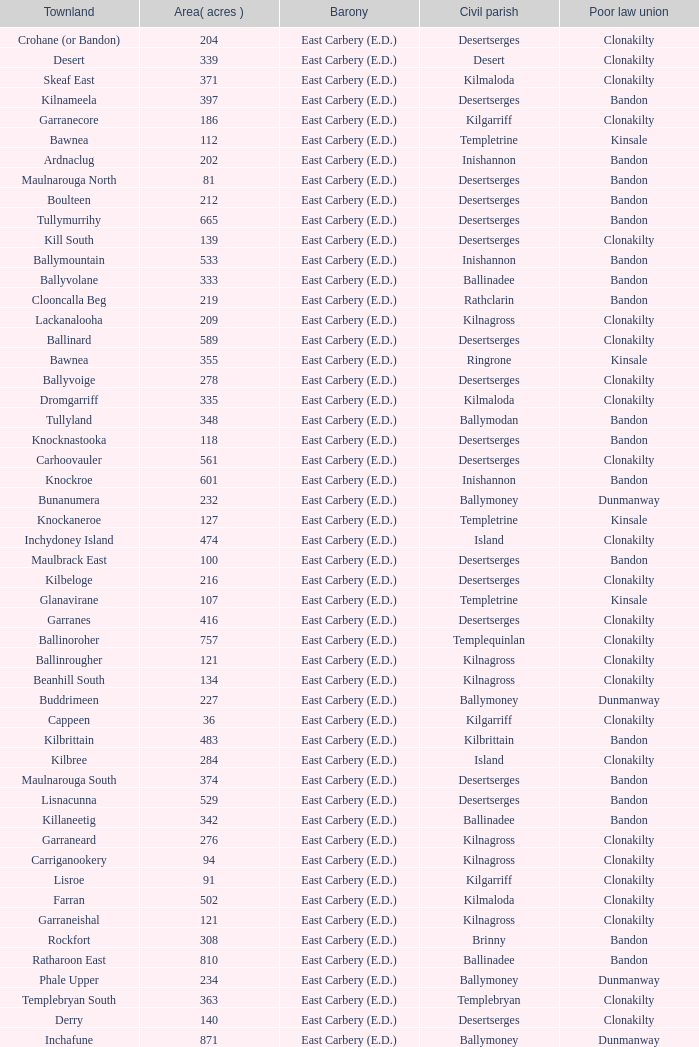What is the poor law union of the Kilmaloda townland? Clonakilty. Give me the full table as a dictionary. {'header': ['Townland', 'Area( acres )', 'Barony', 'Civil parish', 'Poor law union'], 'rows': [['Crohane (or Bandon)', '204', 'East Carbery (E.D.)', 'Desertserges', 'Clonakilty'], ['Desert', '339', 'East Carbery (E.D.)', 'Desert', 'Clonakilty'], ['Skeaf East', '371', 'East Carbery (E.D.)', 'Kilmaloda', 'Clonakilty'], ['Kilnameela', '397', 'East Carbery (E.D.)', 'Desertserges', 'Bandon'], ['Garranecore', '186', 'East Carbery (E.D.)', 'Kilgarriff', 'Clonakilty'], ['Bawnea', '112', 'East Carbery (E.D.)', 'Templetrine', 'Kinsale'], ['Ardnaclug', '202', 'East Carbery (E.D.)', 'Inishannon', 'Bandon'], ['Maulnarouga North', '81', 'East Carbery (E.D.)', 'Desertserges', 'Bandon'], ['Boulteen', '212', 'East Carbery (E.D.)', 'Desertserges', 'Bandon'], ['Tullymurrihy', '665', 'East Carbery (E.D.)', 'Desertserges', 'Bandon'], ['Kill South', '139', 'East Carbery (E.D.)', 'Desertserges', 'Clonakilty'], ['Ballymountain', '533', 'East Carbery (E.D.)', 'Inishannon', 'Bandon'], ['Ballyvolane', '333', 'East Carbery (E.D.)', 'Ballinadee', 'Bandon'], ['Clooncalla Beg', '219', 'East Carbery (E.D.)', 'Rathclarin', 'Bandon'], ['Lackanalooha', '209', 'East Carbery (E.D.)', 'Kilnagross', 'Clonakilty'], ['Ballinard', '589', 'East Carbery (E.D.)', 'Desertserges', 'Clonakilty'], ['Bawnea', '355', 'East Carbery (E.D.)', 'Ringrone', 'Kinsale'], ['Ballyvoige', '278', 'East Carbery (E.D.)', 'Desertserges', 'Clonakilty'], ['Dromgarriff', '335', 'East Carbery (E.D.)', 'Kilmaloda', 'Clonakilty'], ['Tullyland', '348', 'East Carbery (E.D.)', 'Ballymodan', 'Bandon'], ['Knocknastooka', '118', 'East Carbery (E.D.)', 'Desertserges', 'Bandon'], ['Carhoovauler', '561', 'East Carbery (E.D.)', 'Desertserges', 'Clonakilty'], ['Knockroe', '601', 'East Carbery (E.D.)', 'Inishannon', 'Bandon'], ['Bunanumera', '232', 'East Carbery (E.D.)', 'Ballymoney', 'Dunmanway'], ['Knockaneroe', '127', 'East Carbery (E.D.)', 'Templetrine', 'Kinsale'], ['Inchydoney Island', '474', 'East Carbery (E.D.)', 'Island', 'Clonakilty'], ['Maulbrack East', '100', 'East Carbery (E.D.)', 'Desertserges', 'Bandon'], ['Kilbeloge', '216', 'East Carbery (E.D.)', 'Desertserges', 'Clonakilty'], ['Glanavirane', '107', 'East Carbery (E.D.)', 'Templetrine', 'Kinsale'], ['Garranes', '416', 'East Carbery (E.D.)', 'Desertserges', 'Clonakilty'], ['Ballinoroher', '757', 'East Carbery (E.D.)', 'Templequinlan', 'Clonakilty'], ['Ballinrougher', '121', 'East Carbery (E.D.)', 'Kilnagross', 'Clonakilty'], ['Beanhill South', '134', 'East Carbery (E.D.)', 'Kilnagross', 'Clonakilty'], ['Buddrimeen', '227', 'East Carbery (E.D.)', 'Ballymoney', 'Dunmanway'], ['Cappeen', '36', 'East Carbery (E.D.)', 'Kilgarriff', 'Clonakilty'], ['Kilbrittain', '483', 'East Carbery (E.D.)', 'Kilbrittain', 'Bandon'], ['Kilbree', '284', 'East Carbery (E.D.)', 'Island', 'Clonakilty'], ['Maulnarouga South', '374', 'East Carbery (E.D.)', 'Desertserges', 'Bandon'], ['Lisnacunna', '529', 'East Carbery (E.D.)', 'Desertserges', 'Bandon'], ['Killaneetig', '342', 'East Carbery (E.D.)', 'Ballinadee', 'Bandon'], ['Garraneard', '276', 'East Carbery (E.D.)', 'Kilnagross', 'Clonakilty'], ['Carriganookery', '94', 'East Carbery (E.D.)', 'Kilnagross', 'Clonakilty'], ['Lisroe', '91', 'East Carbery (E.D.)', 'Kilgarriff', 'Clonakilty'], ['Farran', '502', 'East Carbery (E.D.)', 'Kilmaloda', 'Clonakilty'], ['Garraneishal', '121', 'East Carbery (E.D.)', 'Kilnagross', 'Clonakilty'], ['Rockfort', '308', 'East Carbery (E.D.)', 'Brinny', 'Bandon'], ['Ratharoon East', '810', 'East Carbery (E.D.)', 'Ballinadee', 'Bandon'], ['Phale Upper', '234', 'East Carbery (E.D.)', 'Ballymoney', 'Dunmanway'], ['Templebryan South', '363', 'East Carbery (E.D.)', 'Templebryan', 'Clonakilty'], ['Derry', '140', 'East Carbery (E.D.)', 'Desertserges', 'Clonakilty'], ['Inchafune', '871', 'East Carbery (E.D.)', 'Ballymoney', 'Dunmanway'], ['Moanarone', '235', 'East Carbery (E.D.)', 'Ballymodan', 'Bandon'], ['Knockmacool', '241', 'East Carbery (E.D.)', 'Desertserges', 'Bandon'], ['Shanaway East', '386', 'East Carbery (E.D.)', 'Ballymoney', 'Dunmanway'], ['Youghals', '109', 'East Carbery (E.D.)', 'Island', 'Clonakilty'], ['Farranagow', '99', 'East Carbery (E.D.)', 'Inishannon', 'Bandon'], ['Kilgobbin', '1263', 'East Carbery (E.D.)', 'Ballinadee', 'Bandon'], ['Ballymacowen', '522', 'East Carbery (E.D.)', 'Kilnagross', 'Clonakilty'], ['Kilshinahan', '528', 'East Carbery (E.D.)', 'Kilbrittain', 'Bandon'], ['Cloghmacsimon', '258', 'East Carbery (E.D.)', 'Ballymodan', 'Bandon'], ['Shanaway West', '266', 'East Carbery (E.D.)', 'Ballymoney', 'Dunmanway'], ['Lisheen', '44', 'East Carbery (E.D.)', 'Templetrine', 'Kinsale'], ['Garraneanasig', '270', 'East Carbery (E.D.)', 'Ringrone', 'Kinsale'], ['Crohane West', '69', 'East Carbery (E.D.)', 'Desertserges', 'Clonakilty'], ['Knockanreagh', '139', 'East Carbery (E.D.)', 'Ballymodan', 'Bandon'], ['Castlederry', '148', 'East Carbery (E.D.)', 'Desertserges', 'Clonakilty'], ['Maulbrack West', '242', 'East Carbery (E.D.)', 'Desertserges', 'Bandon'], ['Reenroe', '123', 'East Carbery (E.D.)', 'Kilgarriff', 'Clonakilty'], ['Ballybeg', '261', 'East Carbery (E.D.)', 'Kilbrittain', 'Bandon'], ['Derrigra', '177', 'East Carbery (E.D.)', 'Ballymoney', 'Dunmanway'], ['Beanhill North', '108', 'East Carbery (E.D.)', 'Kilnagross', 'Clonakilty'], ['Ballinvronig', '319', 'East Carbery (E.D.)', 'Templetrine', 'Kinsale'], ['Knockeenbwee Upper', '229', 'East Carbery (E.D.)', 'Dromdaleague', 'Skibbereen'], ['Clogagh North', '173', 'East Carbery (E.D.)', 'Kilmaloda', 'Clonakilty'], ['Crohane East', '108', 'East Carbery (E.D.)', 'Desertserges', 'Clonakilty'], ['Ballylangley', '288', 'East Carbery (E.D.)', 'Ballymodan', 'Bandon'], ['Knockacullen', '381', 'East Carbery (E.D.)', 'Desertserges', 'Clonakilty'], ['Clashafree', '477', 'East Carbery (E.D.)', 'Ballymodan', 'Bandon'], ['Scartagh', '186', 'East Carbery (E.D.)', 'Kilgarriff', 'Clonakilty'], ['Tawnies Upper', '321', 'East Carbery (E.D.)', 'Kilgarriff', 'Clonakilty'], ['Templebryan North', '436', 'East Carbery (E.D.)', 'Templebryan', 'Clonakilty'], ['Miles', '268', 'East Carbery (E.D.)', 'Kilgarriff', 'Clonakilty'], ['Knocknagappul', '507', 'East Carbery (E.D.)', 'Ballinadee', 'Bandon'], ['Knocks', '540', 'East Carbery (E.D.)', 'Desertserges', 'Clonakilty'], ['Maulrour', '340', 'East Carbery (E.D.)', 'Kilmaloda', 'Clonakilty'], ['Garranefeen', '478', 'East Carbery (E.D.)', 'Rathclarin', 'Bandon'], ['Dromgarriff West', '138', 'East Carbery (E.D.)', 'Kilnagross', 'Clonakilty'], ['Kilmacsimon', '219', 'East Carbery (E.D.)', 'Ballinadee', 'Bandon'], ['Tawnies Lower', '238', 'East Carbery (E.D.)', 'Kilgarriff', 'Clonakilty'], ['Lisheenaleen', '267', 'East Carbery (E.D.)', 'Rathclarin', 'Bandon'], ['Baltinakin', '333', 'East Carbery (E.D.)', 'Kilbrittain', 'Bandon'], ['Curraghcrowly West', '242', 'East Carbery (E.D.)', 'Ballymoney', 'Dunmanway'], ['Ahalisky', '886', 'East Carbery (E.D.)', 'Kilmaloda', 'Clonakilty'], ['Cloncouse', '241', 'East Carbery (E.D.)', 'Ballinadee', 'Bandon'], ['Dromgarriff East', '385', 'East Carbery (E.D.)', 'Kilnagross', 'Clonakilty'], ['Tullig', '135', 'East Carbery (E.D.)', 'Kilmaloda', 'Clonakilty'], ['Maulnageragh', '135', 'East Carbery (E.D.)', 'Kilnagross', 'Clonakilty'], ['Garranereagh', '398', 'East Carbery (E.D.)', 'Ringrone', 'Kinsale'], ['Clonbouig', '219', 'East Carbery (E.D.)', 'Ringrone', 'Kinsale'], ['Dromkeen', '673', 'East Carbery (E.D.)', 'Inishannon', 'Bandon'], ['Carrigcannon', '59', 'East Carbery (E.D.)', 'Ballymodan', 'Bandon'], ['Knocknacurra', '422', 'East Carbery (E.D.)', 'Ballinadee', 'Bandon'], ['Hacketstown', '182', 'East Carbery (E.D.)', 'Templetrine', 'Kinsale'], ['Lisbehegh', '255', 'East Carbery (E.D.)', 'Desertserges', 'Clonakilty'], ['Fourcuil', '125', 'East Carbery (E.D.)', 'Kilgarriff', 'Clonakilty'], ['Ardkitt West', '407', 'East Carbery (E.D.)', 'Desertserges', 'Bandon'], ['Carrig', '410', 'East Carbery (E.D.)', 'Kilmaloda', 'Clonakilty'], ['Crohane (or Bandon)', '250', 'East Carbery (E.D.)', 'Kilnagross', 'Clonakilty'], ['Killeen', '309', 'East Carbery (E.D.)', 'Desertserges', 'Clonakilty'], ['Knocknanuss', '394', 'East Carbery (E.D.)', 'Desertserges', 'Clonakilty'], ['Carrig', '165', 'East Carbery (E.D.)', 'Templequinlan', 'Clonakilty'], ['Garranbeg', '170', 'East Carbery (E.D.)', 'Ballymodan', 'Bandon'], ['Glanavirane', '91', 'East Carbery (E.D.)', 'Ringrone', 'Kinsale'], ['Knockeencon', '108', 'East Carbery (E.D.)', 'Tullagh', 'Skibbereen'], ['Clonbouig', '209', 'East Carbery (E.D.)', 'Templetrine', 'Kinsale'], ['Aghyohil Beg', '94', 'East Carbery (E.D.)', 'Desertserges', 'Bandon'], ['Breaghna', '333', 'East Carbery (E.D.)', 'Desertserges', 'Bandon'], ['Ballydownis West', '60', 'East Carbery (E.D.)', 'Templetrine', 'Kinsale'], ['Curraghcrowly East', '327', 'East Carbery (E.D.)', 'Ballymoney', 'Dunmanway'], ['Killanamaul', '220', 'East Carbery (E.D.)', 'Kilbrittain', 'Bandon'], ['Corravreeda East', '258', 'East Carbery (E.D.)', 'Ballymodan', 'Bandon'], ['Fourcuil', '244', 'East Carbery (E.D.)', 'Templebryan', 'Clonakilty'], ['Ballydownis', '73', 'East Carbery (E.D.)', 'Ringrone', 'Kinsale'], ['Cloonderreen', '291', 'East Carbery (E.D.)', 'Rathclarin', 'Bandon'], ['Kilrush', '189', 'East Carbery (E.D.)', 'Desertserges', 'Bandon'], ['Cripplehill', '125', 'East Carbery (E.D.)', 'Ballymodan', 'Bandon'], ['Skeaf West', '477', 'East Carbery (E.D.)', 'Kilmaloda', 'Clonakilty'], ['Ballynacarriga', '124', 'East Carbery (E.D.)', 'Ballymoney', 'Dunmanway'], ['Derrigra West', '320', 'East Carbery (E.D.)', 'Ballymoney', 'Dunmanway'], ['Knockskagh', '489', 'East Carbery (E.D.)', 'Kilgarriff', 'Clonakilty'], ['Steilaneigh', '42', 'East Carbery (E.D.)', 'Templetrine', 'Kinsale'], ['Farrannasheshery', '304', 'East Carbery (E.D.)', 'Desertserges', 'Bandon'], ['Ballynascubbig', '272', 'East Carbery (E.D.)', 'Templetrine', 'Kinsale'], ['Rochestown', '104', 'East Carbery (E.D.)', 'Templetrine', 'Kinsale'], ['Shanaway Middle', '296', 'East Carbery (E.D.)', 'Ballymoney', 'Dunmanway'], ['Currarane', '100', 'East Carbery (E.D.)', 'Templetrine', 'Kinsale'], ['Derrymeeleen', '441', 'East Carbery (E.D.)', 'Desertserges', 'Clonakilty'], ['Knockbrown', '510', 'East Carbery (E.D.)', 'Kilmaloda', 'Bandon'], ['Clogagh South', '282', 'East Carbery (E.D.)', 'Kilmaloda', 'Clonakilty'], ['Knockbrown', '312', 'East Carbery (E.D.)', 'Kilbrittain', 'Bandon'], ['Kilvinane', '199', 'East Carbery (E.D.)', 'Ballymoney', 'Dunmanway'], ['Maulskinlahane', '245', 'East Carbery (E.D.)', 'Kilbrittain', 'Bandon'], ['Glanavaud', '98', 'East Carbery (E.D.)', 'Ringrone', 'Kinsale'], ['Barleyfield', '795', 'East Carbery (E.D.)', 'Rathclarin', 'Bandon'], ['Ardea', '295', 'East Carbery (E.D.)', 'Ballymoney', 'Dunmanway'], ['Drombofinny', '86', 'East Carbery (E.D.)', 'Desertserges', 'Bandon'], ['Glanduff', '464', 'East Carbery (E.D.)', 'Rathclarin', 'Bandon'], ['Clooncalla More', '543', 'East Carbery (E.D.)', 'Rathclarin', 'Bandon'], ['Skevanish', '359', 'East Carbery (E.D.)', 'Inishannon', 'Bandon'], ['Rockhouse', '82', 'East Carbery (E.D.)', 'Ballinadee', 'Bandon'], ['Farrannagark', '290', 'East Carbery (E.D.)', 'Rathclarin', 'Bandon'], ['Burren', '639', 'East Carbery (E.D.)', 'Rathclarin', 'Bandon'], ['Grillagh', '136', 'East Carbery (E.D.)', 'Kilnagross', 'Clonakilty'], ['Curranure', '362', 'East Carbery (E.D.)', 'Inishannon', 'Bandon'], ['Kilvurra', '356', 'East Carbery (E.D.)', 'Ballymoney', 'Dunmanway'], ['Edencurra', '516', 'East Carbery (E.D.)', 'Ballymoney', 'Dunmanway'], ['Shanakill', '197', 'East Carbery (E.D.)', 'Rathclarin', 'Bandon'], ['Ardkitt East', '283', 'East Carbery (E.D.)', 'Desertserges', 'Bandon'], ['Carrigcannon', '122', 'East Carbery (E.D.)', 'Ringrone', 'Kinsale'], ['Crohane', '91', 'East Carbery (E.D.)', 'Kilnagross', 'Clonakilty'], ['Kilmaloda', '634', 'East Carbery (E.D.)', 'Kilmaloda', 'Clonakilty'], ['Carrigeen', '210', 'East Carbery (E.D.)', 'Ballymoney', 'Dunmanway'], ['Currane', '156', 'East Carbery (E.D.)', 'Desertserges', 'Clonakilty'], ['Corravreeda West', '169', 'East Carbery (E.D.)', 'Ballymodan', 'Bandon'], ['Reengarrigeen', '560', 'East Carbery (E.D.)', 'Kilmaloda', 'Clonakilty'], ['Knoppoge', '567', 'East Carbery (E.D.)', 'Kilbrittain', 'Bandon'], ['Kilcaskan', '221', 'East Carbery (E.D.)', 'Ballymoney', 'Dunmanway'], ['Skeaf', '452', 'East Carbery (E.D.)', 'Kilmaloda', 'Clonakilty'], ['Carhoogarriff', '281', 'East Carbery (E.D.)', 'Kilnagross', 'Clonakilty'], ['Coolmain', '450', 'East Carbery (E.D.)', 'Ringrone', 'Kinsale'], ['Killeens', '132', 'East Carbery (E.D.)', 'Templetrine', 'Kinsale'], ['Lissaphooca', '513', 'East Carbery (E.D.)', 'Ballymodan', 'Bandon'], ['Phale Lower', '287', 'East Carbery (E.D.)', 'Ballymoney', 'Dunmanway'], ['Garranecore', '144', 'East Carbery (E.D.)', 'Templebryan', 'Clonakilty'], ['Bally More', '418', 'East Carbery (E.D.)', 'Kilbrittain', 'Bandon'], ['Kill North', '136', 'East Carbery (E.D.)', 'Desertserges', 'Clonakilty'], ['Knockeenbwee Lower', '213', 'East Carbery (E.D.)', 'Dromdaleague', 'Skibbereen'], ['Garranure', '436', 'East Carbery (E.D.)', 'Ballymoney', 'Dunmanway'], ['Carrigroe', '276', 'East Carbery (E.D.)', 'Desertserges', 'Bandon'], ['Ratharoon West', '383', 'East Carbery (E.D.)', 'Ballinadee', 'Bandon'], ['Clogheenavodig', '70', 'East Carbery (E.D.)', 'Ballymodan', 'Bandon'], ['Ardacrow', '519', 'East Carbery (E.D.)', 'Rathclarin', 'Bandon'], ['Currabeg', '173', 'East Carbery (E.D.)', 'Ballymoney', 'Dunmanway'], ['Rathdrought', '1242', 'East Carbery (E.D.)', 'Ballinadee', 'Bandon'], ['Cloghane', '488', 'East Carbery (E.D.)', 'Ballinadee', 'Bandon'], ['Monteen', '589', 'East Carbery (E.D.)', 'Kilmaloda', 'Clonakilty'], ['Cashelisky', '368', 'East Carbery (E.D.)', 'Island', 'Clonakilty'], ['Aghyohil More', '178', 'East Carbery (E.D.)', 'Desertserges', 'Bandon'], ['Clashreagh', '132', 'East Carbery (E.D.)', 'Templetrine', 'Kinsale'], ['Cloheen', '360', 'East Carbery (E.D.)', 'Kilgarriff', 'Clonakilty'], ['Kildarra', '463', 'East Carbery (E.D.)', 'Ballinadee', 'Bandon'], ['Kilgarriff', '835', 'East Carbery (E.D.)', 'Kilgarriff', 'Clonakilty'], ['Tullyland', '506', 'East Carbery (E.D.)', 'Ballinadee', 'Bandon'], ['Lackenagobidane', '48', 'East Carbery (E.D.)', 'Island', 'Clonakilty'], ['Maulnaskehy', '14', 'East Carbery (E.D.)', 'Kilgarriff', 'Clonakilty'], ['Grillagh', '316', 'East Carbery (E.D.)', 'Ballymoney', 'Dunmanway'], ['Ballycatteen', '338', 'East Carbery (E.D.)', 'Rathclarin', 'Bandon'], ['Ballydownis East', '42', 'East Carbery (E.D.)', 'Templetrine', 'Kinsale'], ['Killavarrig', '708', 'East Carbery (E.D.)', 'Timoleague', 'Clonakilty'], ['Garranelahan', '126', 'East Carbery (E.D.)', 'Desertserges', 'Bandon'], ['Curraghgrane More', '110', 'East Carbery (E.D.)', 'Desert', 'Clonakilty'], ['Currarane', '271', 'East Carbery (E.D.)', 'Ringrone', 'Kinsale'], ['Burrane', '410', 'East Carbery (E.D.)', 'Kilmaloda', 'Clonakilty'], ['Lisselane', '429', 'East Carbery (E.D.)', 'Kilnagross', 'Clonakilty'], ['Knockaneady', '393', 'East Carbery (E.D.)', 'Ballymoney', 'Dunmanway'], ['Kilmoylerane North', '306', 'East Carbery (E.D.)', 'Desertserges', 'Clonakilty'], ['Cripplehill', '93', 'East Carbery (E.D.)', 'Kilbrittain', 'Bandon'], ['Madame', '273', 'East Carbery (E.D.)', 'Kilmaloda', 'Clonakilty'], ['Cloheen', '80', 'East Carbery (E.D.)', 'Island', 'Clonakilty'], ['Glan', '194', 'East Carbery (E.D.)', 'Ballymoney', 'Dunmanway'], ['Maulrour', '244', 'East Carbery (E.D.)', 'Desertserges', 'Clonakilty'], ['Kilmoylerane South', '324', 'East Carbery (E.D.)', 'Desertserges', 'Clonakilty'], ['Baurleigh', '885', 'East Carbery (E.D.)', 'Kilbrittain', 'Bandon'], ['Ballinadee', '329', 'East Carbery (E.D.)', 'Ballinadee', 'Bandon'], ['Madame', '41', 'East Carbery (E.D.)', 'Kilnagross', 'Clonakilty'], ['Garryndruig', '856', 'East Carbery (E.D.)', 'Rathclarin', 'Bandon'], ['Maulmane', '219', 'East Carbery (E.D.)', 'Kilbrittain', 'Bandon'], ['Artiteige', '337', 'East Carbery (E.D.)', 'Templetrine', 'Kinsale']]} 